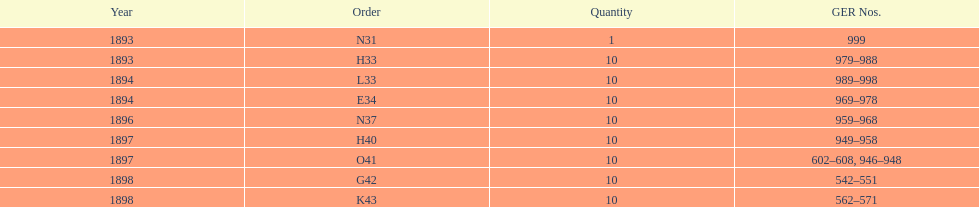What is the position of the most recent year listed? K43. Would you mind parsing the complete table? {'header': ['Year', 'Order', 'Quantity', 'GER Nos.'], 'rows': [['1893', 'N31', '1', '999'], ['1893', 'H33', '10', '979–988'], ['1894', 'L33', '10', '989–998'], ['1894', 'E34', '10', '969–978'], ['1896', 'N37', '10', '959–968'], ['1897', 'H40', '10', '949–958'], ['1897', 'O41', '10', '602–608, 946–948'], ['1898', 'G42', '10', '542–551'], ['1898', 'K43', '10', '562–571']]} 